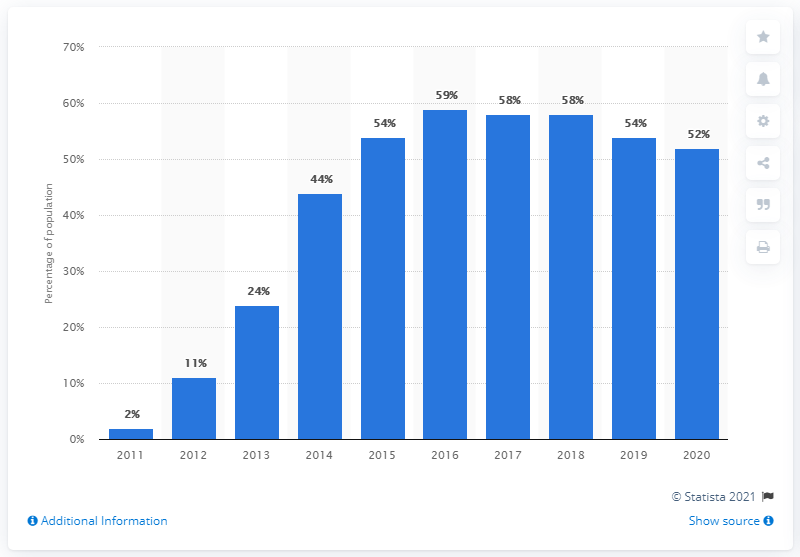Indicate a few pertinent items in this graphic. The tablet penetration rate in the UK in 2020 was 52%. 